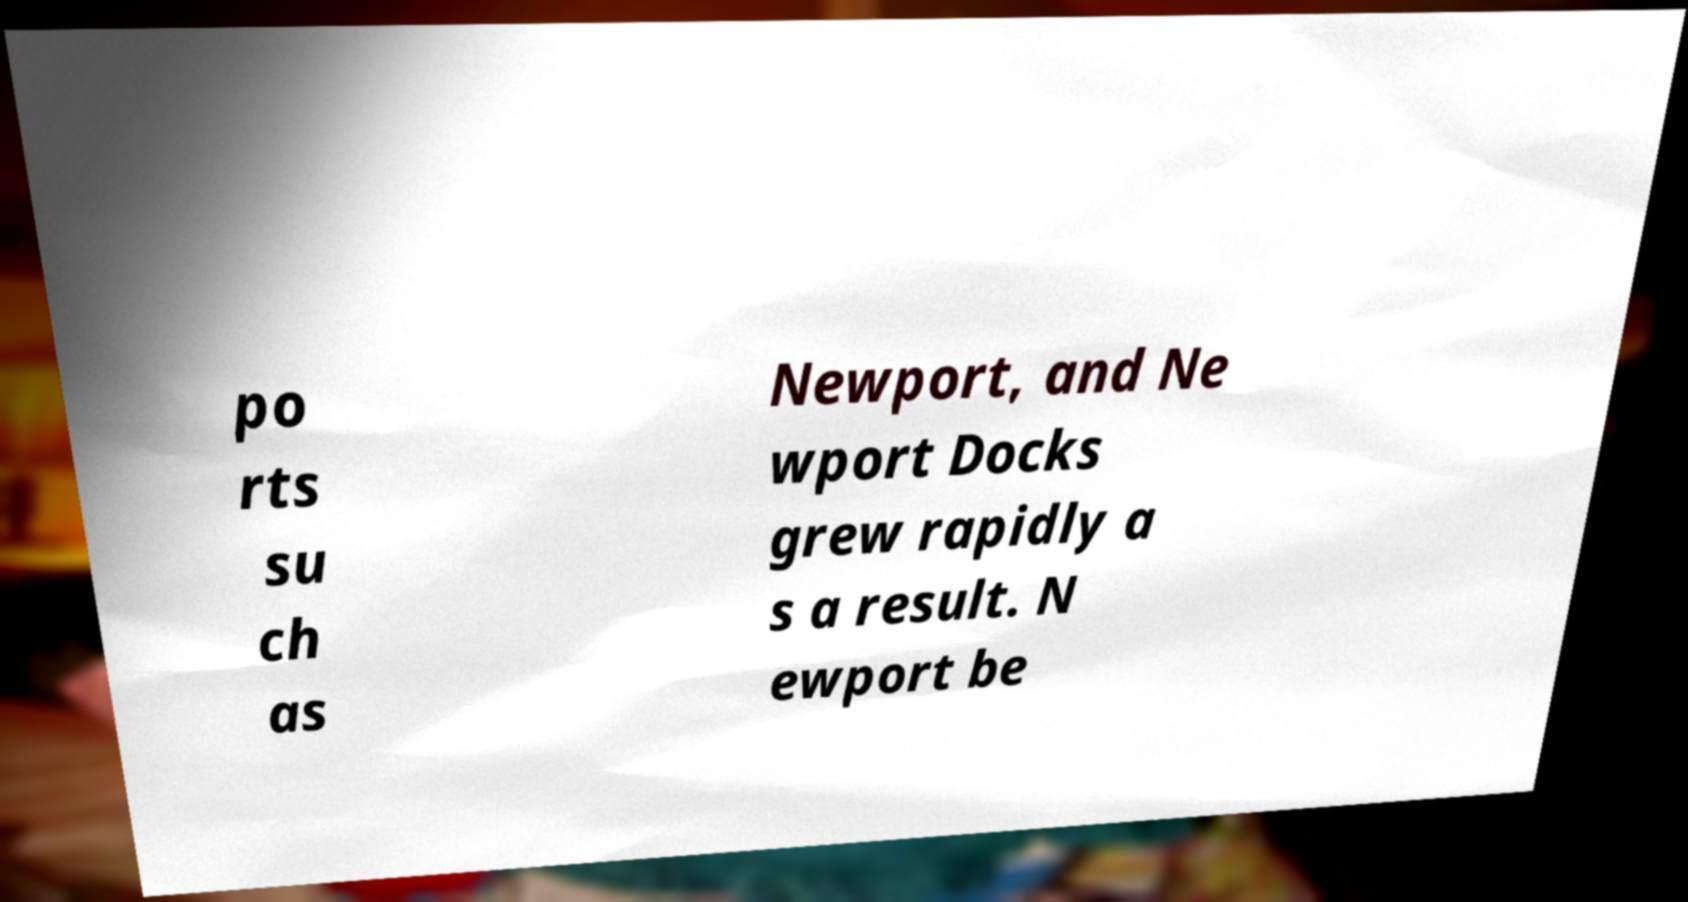For documentation purposes, I need the text within this image transcribed. Could you provide that? po rts su ch as Newport, and Ne wport Docks grew rapidly a s a result. N ewport be 